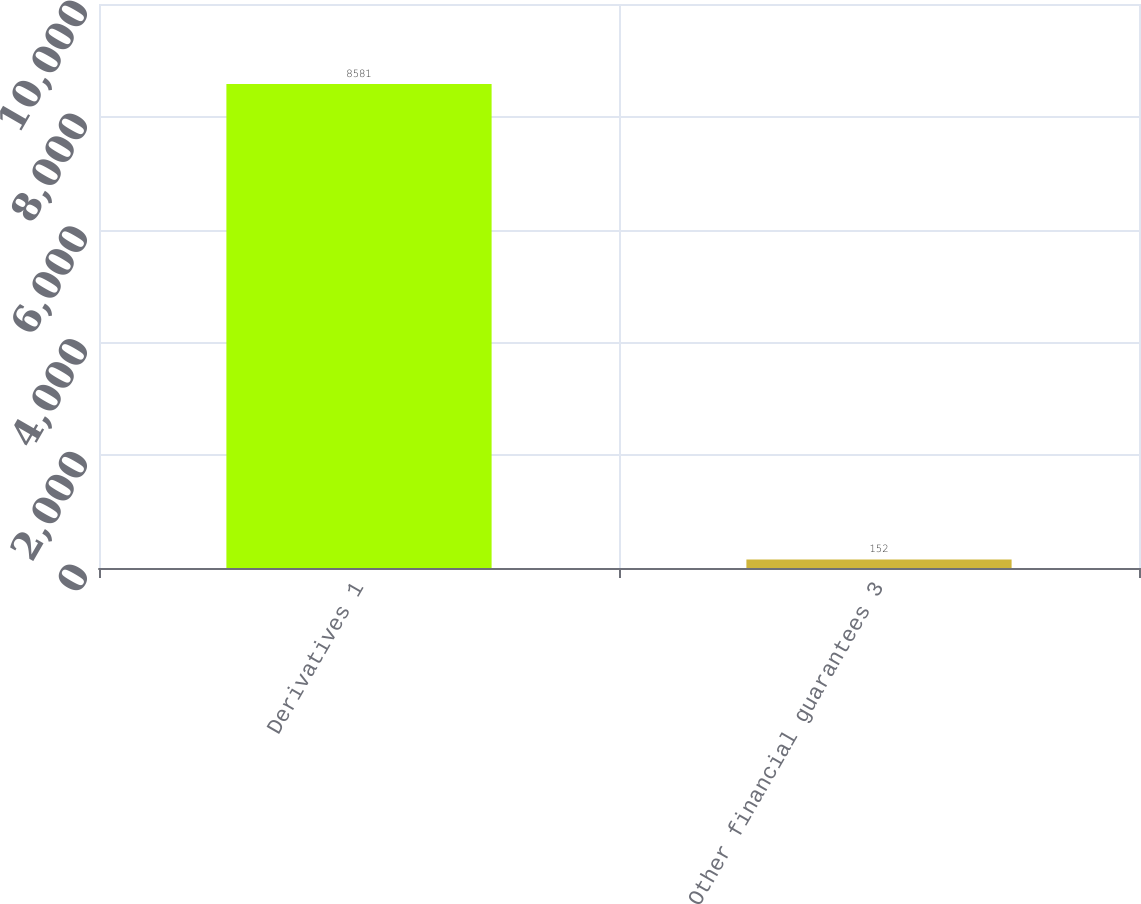Convert chart to OTSL. <chart><loc_0><loc_0><loc_500><loc_500><bar_chart><fcel>Derivatives 1<fcel>Other financial guarantees 3<nl><fcel>8581<fcel>152<nl></chart> 